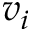<formula> <loc_0><loc_0><loc_500><loc_500>v _ { i }</formula> 